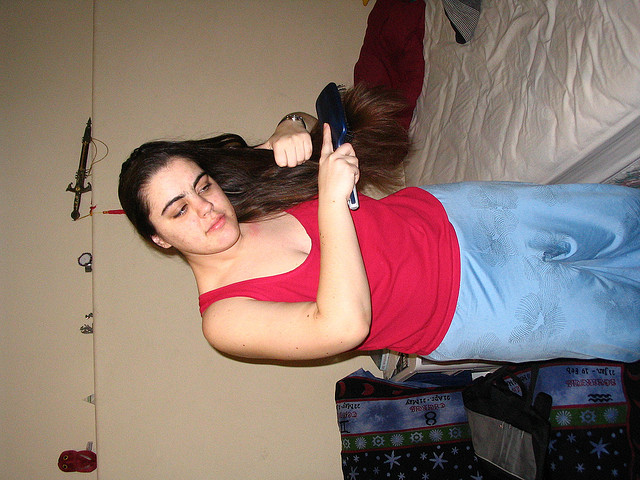Identify and read out the text in this image. 8 